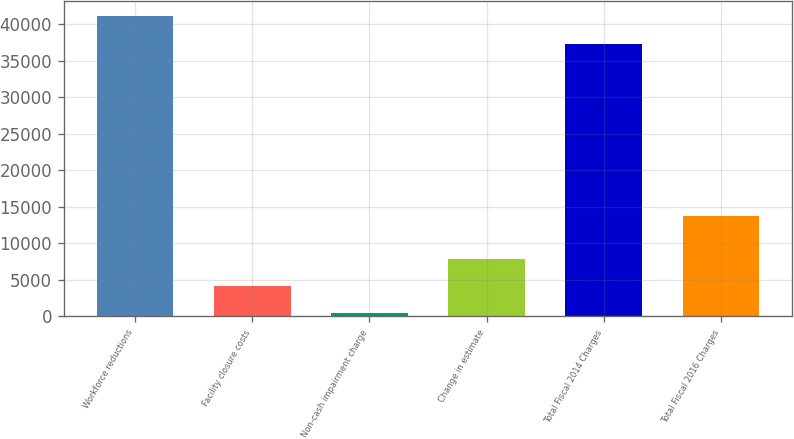Convert chart. <chart><loc_0><loc_0><loc_500><loc_500><bar_chart><fcel>Workforce reductions<fcel>Facility closure costs<fcel>Non-cash impairment charge<fcel>Change in estimate<fcel>Total Fiscal 2014 Charges<fcel>Total Fiscal 2016 Charges<nl><fcel>41066<fcel>4177<fcel>433<fcel>7921<fcel>37322<fcel>13684<nl></chart> 